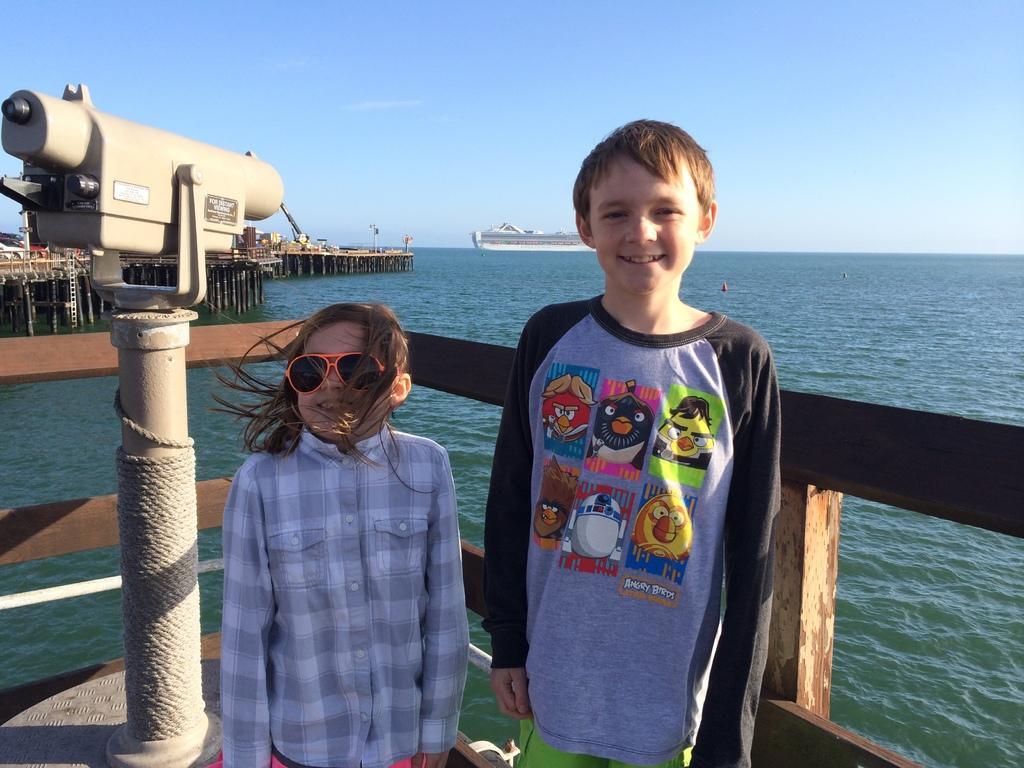Please provide a concise description of this image. In this image in front there are two persons wearing a smile on their faces. Beside them there is binocular. Behind them there is a fence. On the backside there are bridges. We can see a ship in the water. In the background there is the sky. 